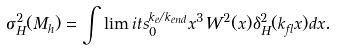<formula> <loc_0><loc_0><loc_500><loc_500>\sigma _ { H } ^ { 2 } ( M _ { h } ) = \int \lim i t s _ { 0 } ^ { k _ { e } / k _ { e n d } } x ^ { 3 } W ^ { 2 } ( x ) \delta _ { H } ^ { 2 } ( k _ { f l } x ) d x .</formula> 